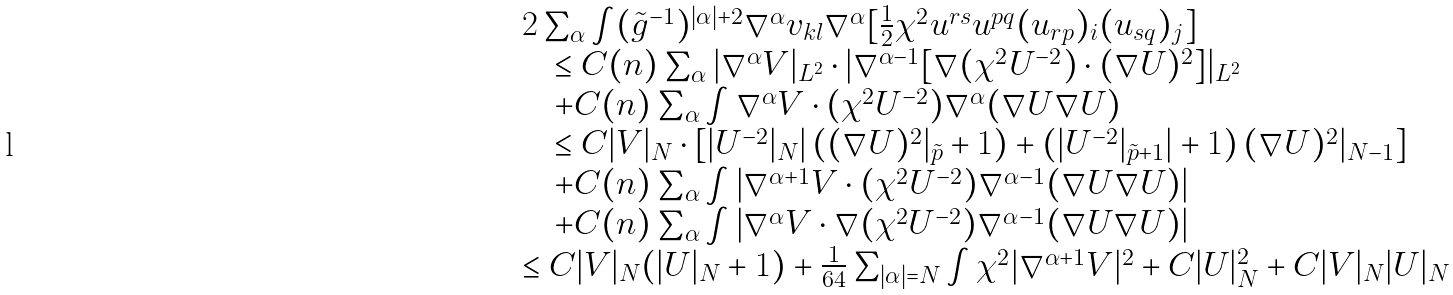<formula> <loc_0><loc_0><loc_500><loc_500>{ \begin{array} { r l } & 2 \sum _ { \alpha } \int ( \tilde { g } ^ { - 1 } ) ^ { | \alpha | + 2 } \nabla ^ { \alpha } v _ { k l } \nabla ^ { \alpha } [ \frac { 1 } { 2 } \chi ^ { 2 } u ^ { r s } u ^ { p q } ( u _ { r p } ) _ { i } ( u _ { s q } ) _ { j } ] \\ & \quad \leq C ( n ) \sum _ { \alpha } | \nabla ^ { \alpha } V | _ { L ^ { 2 } } \cdot | \nabla ^ { \alpha - 1 } [ \nabla ( \chi ^ { 2 } U ^ { - 2 } ) \cdot ( \nabla U ) ^ { 2 } ] | _ { L ^ { 2 } } \\ & \quad + C ( n ) \sum _ { \alpha } \int \nabla ^ { \alpha } V \cdot ( \chi ^ { 2 } U ^ { - 2 } ) \nabla ^ { \alpha } ( \nabla U \nabla U ) \\ & \quad \leq C | V | _ { N } \cdot [ | U ^ { - 2 } | _ { N } | \left ( ( \nabla U ) ^ { 2 } | _ { \tilde { p } } + 1 \right ) + \left ( | U ^ { - 2 } | _ { \tilde { p } + 1 } | + 1 \right ) ( \nabla U ) ^ { 2 } | _ { N - 1 } ] \\ & \quad + C ( n ) \sum _ { \alpha } \int \left | \nabla ^ { \alpha + 1 } V \cdot ( \chi ^ { 2 } U ^ { - 2 } ) \nabla ^ { \alpha - 1 } ( \nabla U \nabla U ) \right | \\ & \quad + C ( n ) \sum _ { \alpha } \int \left | \nabla ^ { \alpha } V \cdot \nabla ( \chi ^ { 2 } U ^ { - 2 } ) \nabla ^ { \alpha - 1 } ( \nabla U \nabla U ) \right | \\ & \leq C | V | _ { N } ( | U | _ { N } + 1 ) + \frac { 1 } { 6 4 } \sum _ { | \alpha | = N } \int \chi ^ { 2 } | \nabla ^ { \alpha + 1 } V | ^ { 2 } + C | U | _ { N } ^ { 2 } + C | V | _ { N } | U | _ { N } \end{array} }</formula> 